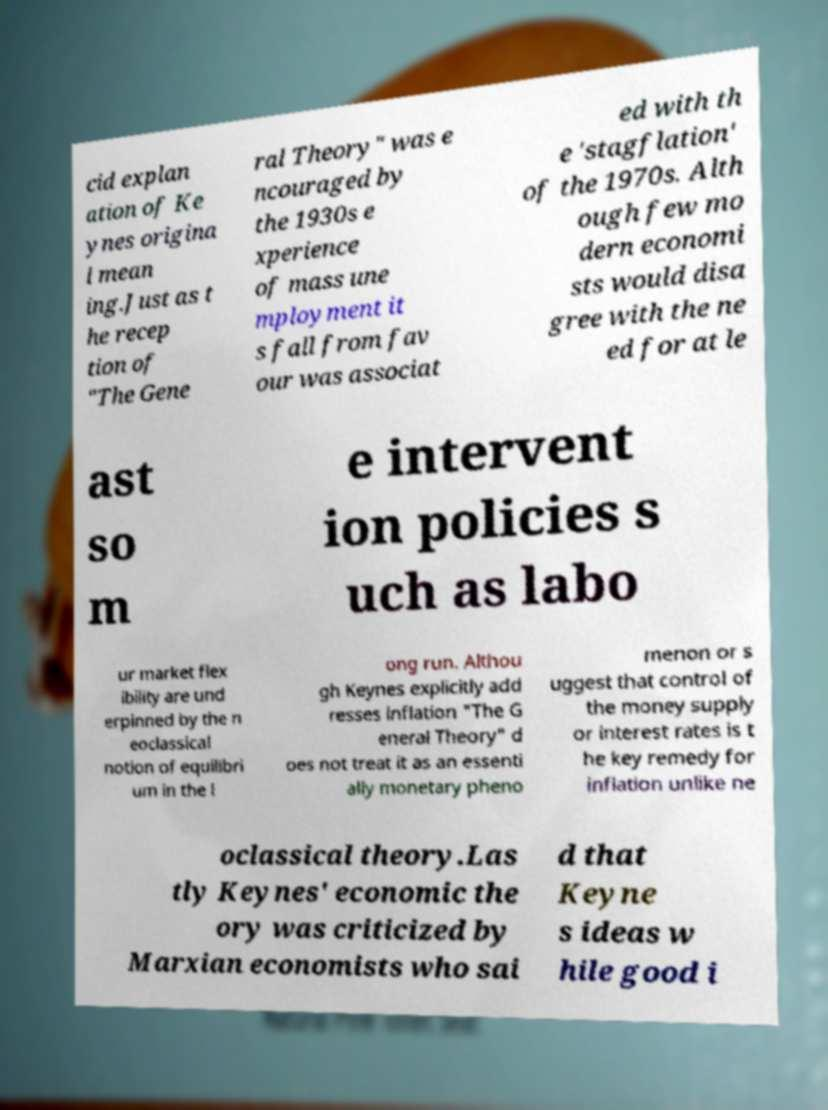Please read and relay the text visible in this image. What does it say? cid explan ation of Ke ynes origina l mean ing.Just as t he recep tion of "The Gene ral Theory" was e ncouraged by the 1930s e xperience of mass une mployment it s fall from fav our was associat ed with th e 'stagflation' of the 1970s. Alth ough few mo dern economi sts would disa gree with the ne ed for at le ast so m e intervent ion policies s uch as labo ur market flex ibility are und erpinned by the n eoclassical notion of equilibri um in the l ong run. Althou gh Keynes explicitly add resses inflation "The G eneral Theory" d oes not treat it as an essenti ally monetary pheno menon or s uggest that control of the money supply or interest rates is t he key remedy for inflation unlike ne oclassical theory.Las tly Keynes' economic the ory was criticized by Marxian economists who sai d that Keyne s ideas w hile good i 